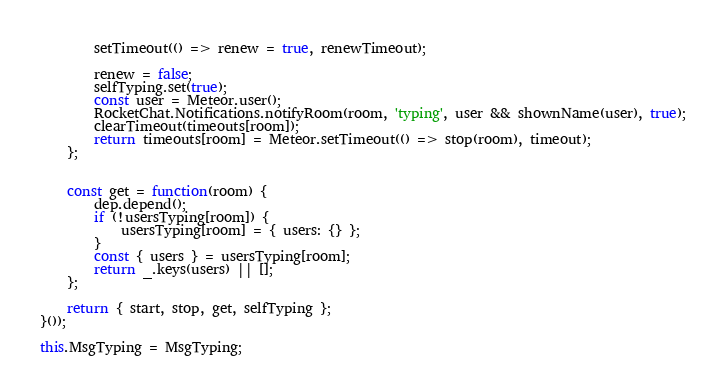<code> <loc_0><loc_0><loc_500><loc_500><_JavaScript_>
		setTimeout(() => renew = true, renewTimeout);

		renew = false;
		selfTyping.set(true);
		const user = Meteor.user();
		RocketChat.Notifications.notifyRoom(room, 'typing', user && shownName(user), true);
		clearTimeout(timeouts[room]);
		return timeouts[room] = Meteor.setTimeout(() => stop(room), timeout);
	};


	const get = function(room) {
		dep.depend();
		if (!usersTyping[room]) {
			usersTyping[room] = { users: {} };
		}
		const { users } = usersTyping[room];
		return _.keys(users) || [];
	};

	return { start, stop, get, selfTyping };
}());

this.MsgTyping = MsgTyping;
</code> 